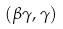Convert formula to latex. <formula><loc_0><loc_0><loc_500><loc_500>( \beta \gamma , \gamma )</formula> 